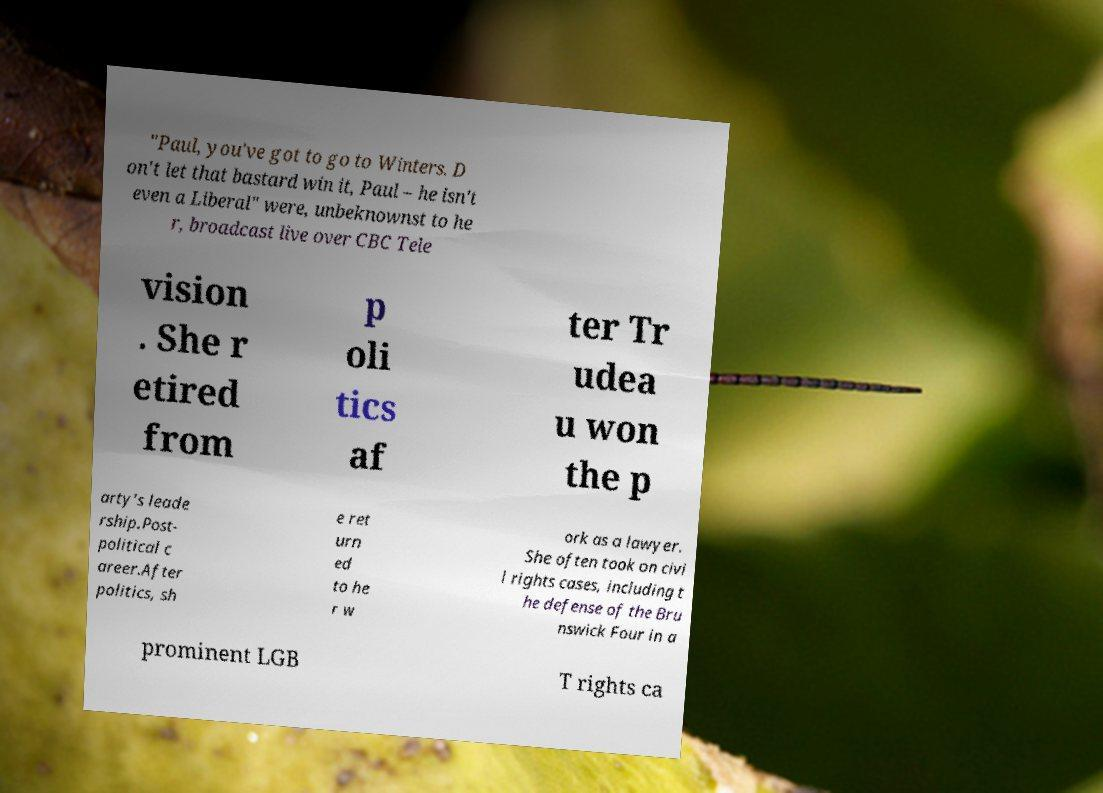Could you assist in decoding the text presented in this image and type it out clearly? "Paul, you've got to go to Winters. D on't let that bastard win it, Paul – he isn't even a Liberal" were, unbeknownst to he r, broadcast live over CBC Tele vision . She r etired from p oli tics af ter Tr udea u won the p arty's leade rship.Post- political c areer.After politics, sh e ret urn ed to he r w ork as a lawyer. She often took on civi l rights cases, including t he defense of the Bru nswick Four in a prominent LGB T rights ca 